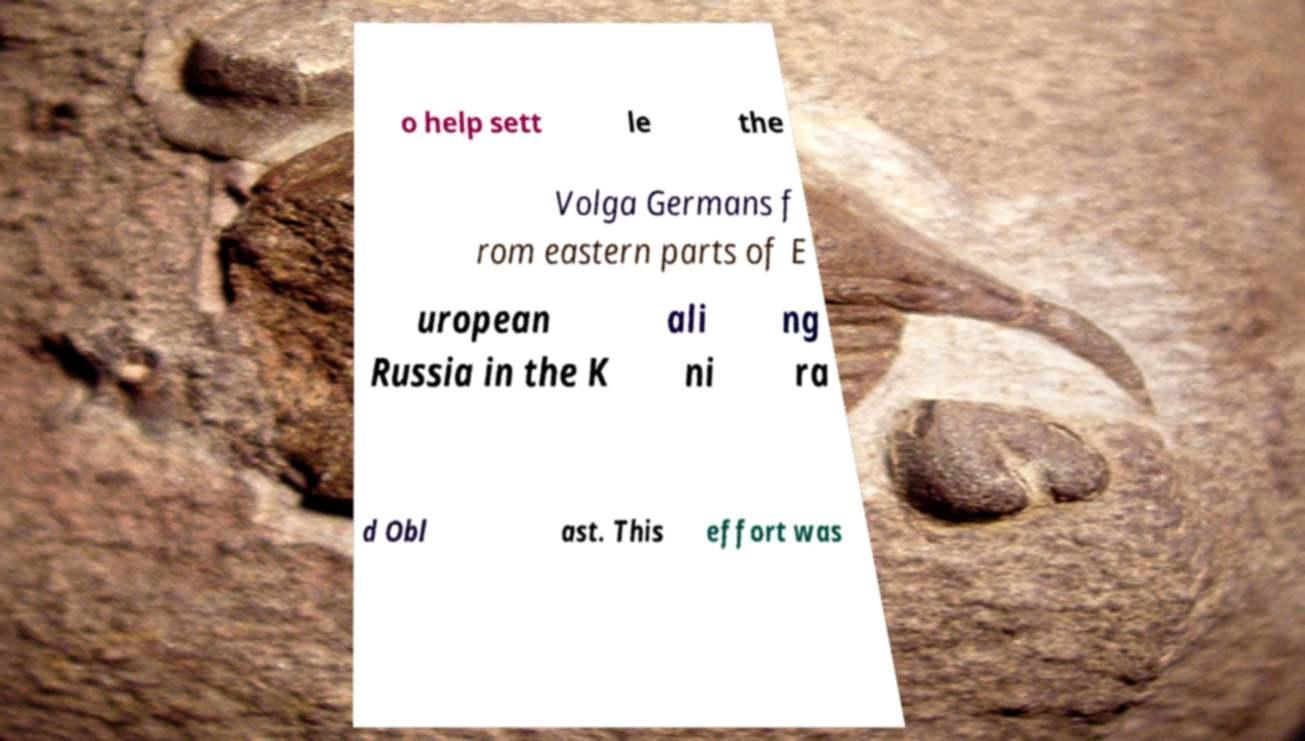Could you assist in decoding the text presented in this image and type it out clearly? o help sett le the Volga Germans f rom eastern parts of E uropean Russia in the K ali ni ng ra d Obl ast. This effort was 